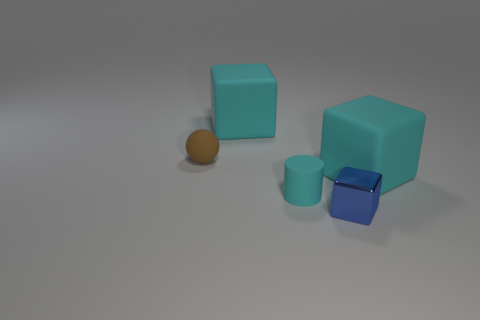Add 1 red balls. How many objects exist? 6 Subtract all cubes. How many objects are left? 2 Add 4 small cyan things. How many small cyan things are left? 5 Add 3 small matte things. How many small matte things exist? 5 Subtract 1 brown spheres. How many objects are left? 4 Subtract all brown matte balls. Subtract all brown rubber blocks. How many objects are left? 4 